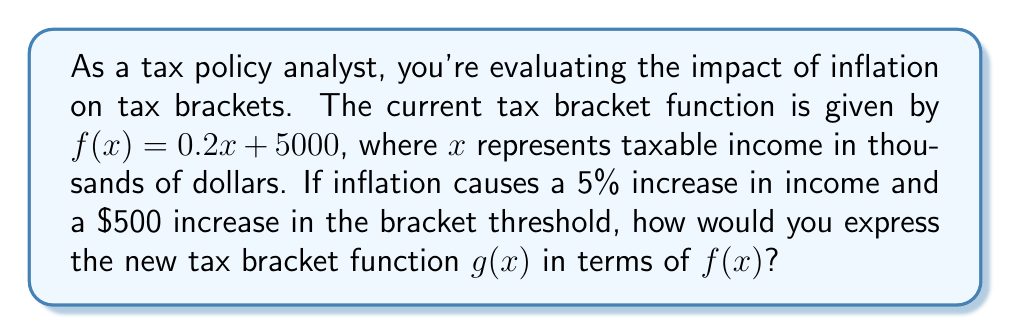Teach me how to tackle this problem. To solve this problem, we need to consider both vertical and horizontal shifts of the original function $f(x)$.

1) First, let's account for the 5% increase in income due to inflation. This means that what was previously $x$ income is now $1.05x$. This results in a horizontal compression by a factor of $\frac{1}{1.05}$:

   $f(1.05x) = 0.2(1.05x) + 5000 = 0.21x + 5000$

2) Next, we need to account for the $500 increase in the bracket threshold. This is a vertical shift upward by 500:

   $f(1.05x) + 500 = 0.21x + 5500$

3) Now, we can express $g(x)$ in terms of $f(x)$:

   $g(x) = f(1.05x) + 500$

This equation shows that the new function $g(x)$ is a result of first compressing $f(x)$ horizontally by a factor of $\frac{1}{1.05}$ (or stretching by 1.05), and then shifting it up by 500.
Answer: $g(x) = f(1.05x) + 500$ 